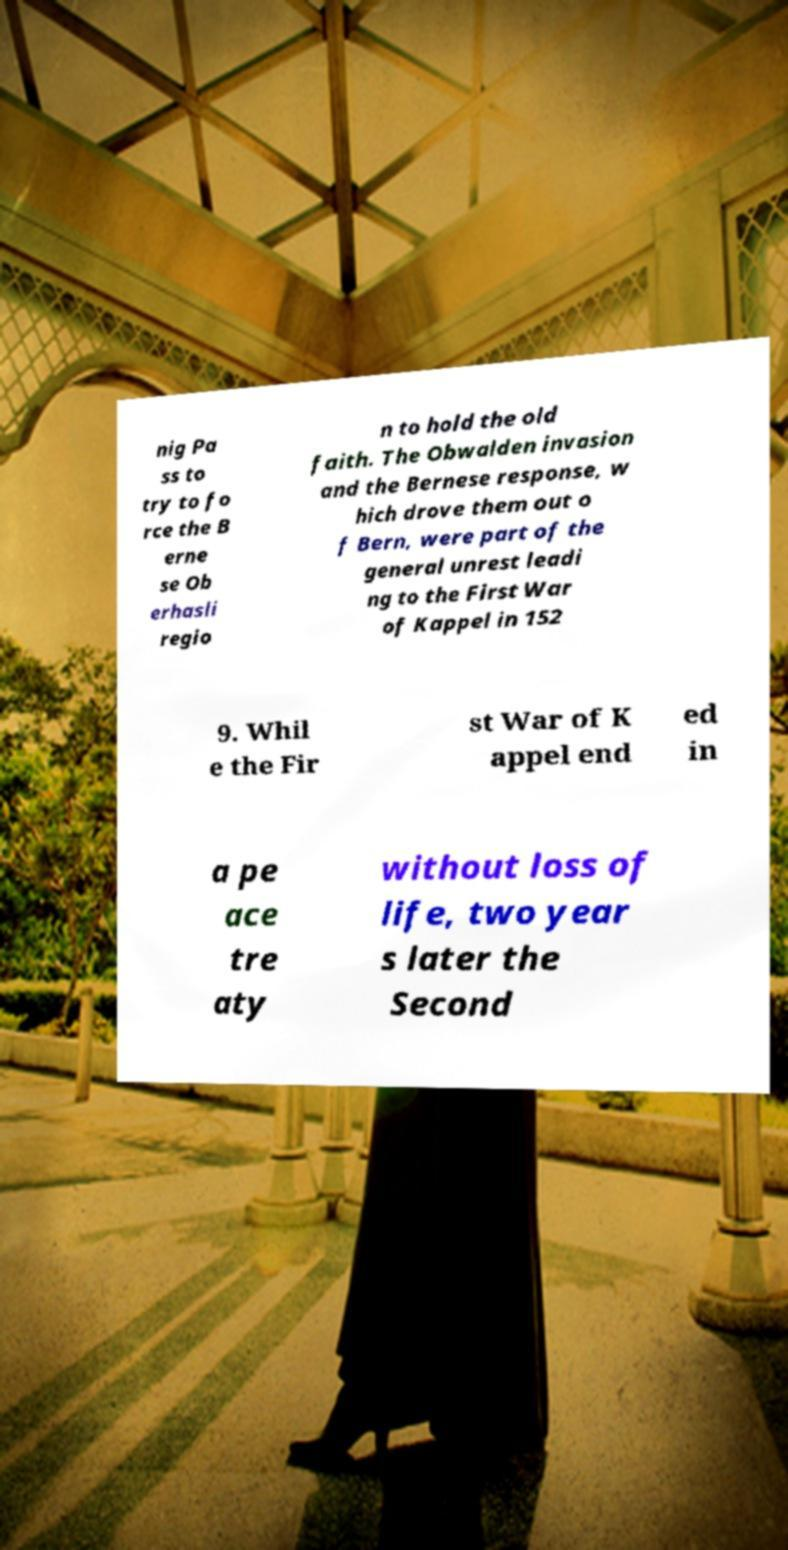Can you accurately transcribe the text from the provided image for me? nig Pa ss to try to fo rce the B erne se Ob erhasli regio n to hold the old faith. The Obwalden invasion and the Bernese response, w hich drove them out o f Bern, were part of the general unrest leadi ng to the First War of Kappel in 152 9. Whil e the Fir st War of K appel end ed in a pe ace tre aty without loss of life, two year s later the Second 